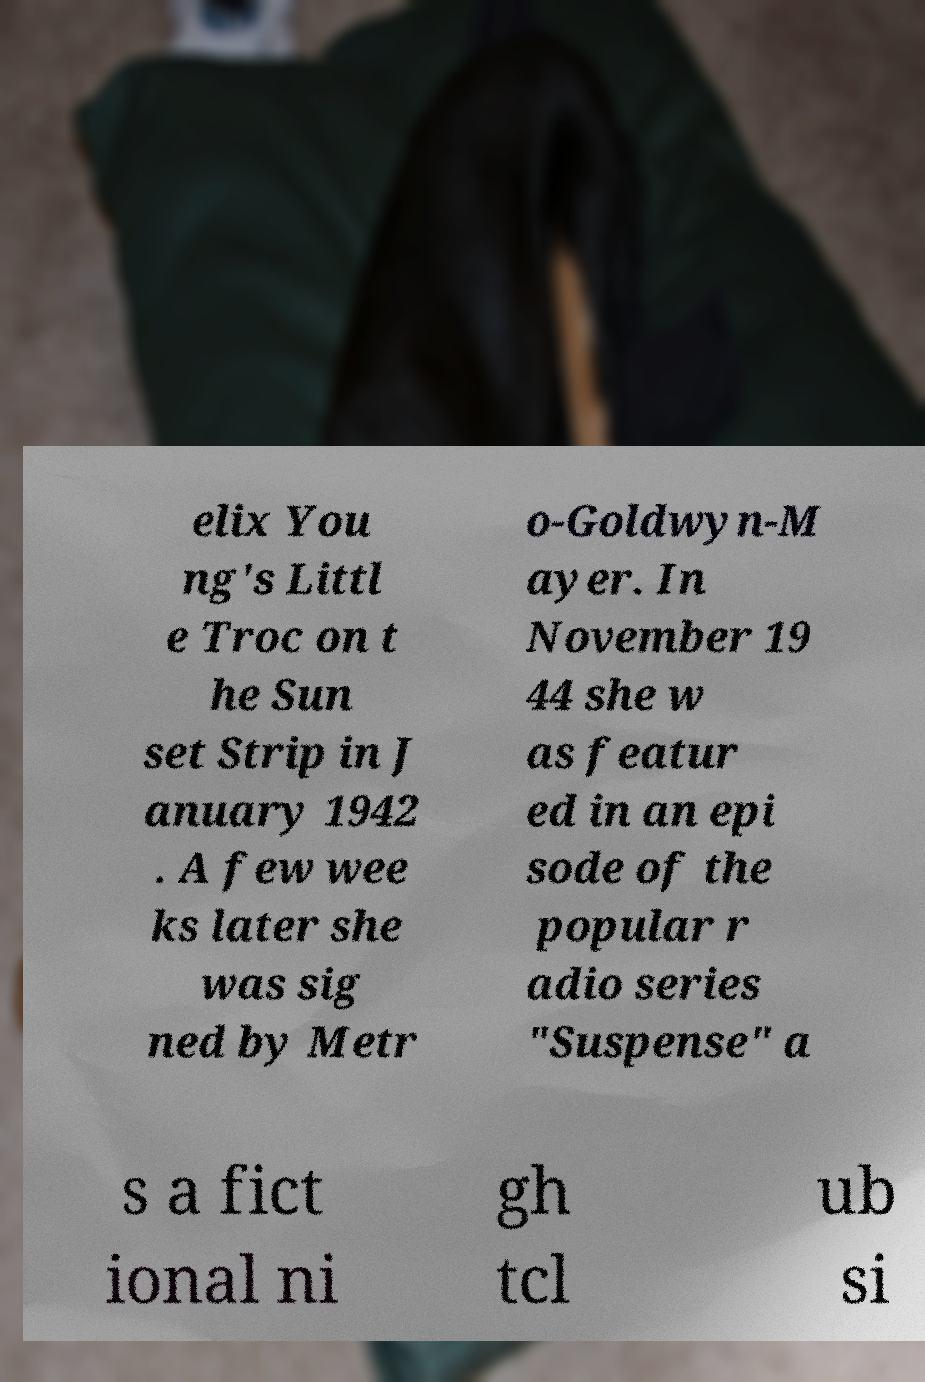For documentation purposes, I need the text within this image transcribed. Could you provide that? elix You ng's Littl e Troc on t he Sun set Strip in J anuary 1942 . A few wee ks later she was sig ned by Metr o-Goldwyn-M ayer. In November 19 44 she w as featur ed in an epi sode of the popular r adio series "Suspense" a s a fict ional ni gh tcl ub si 